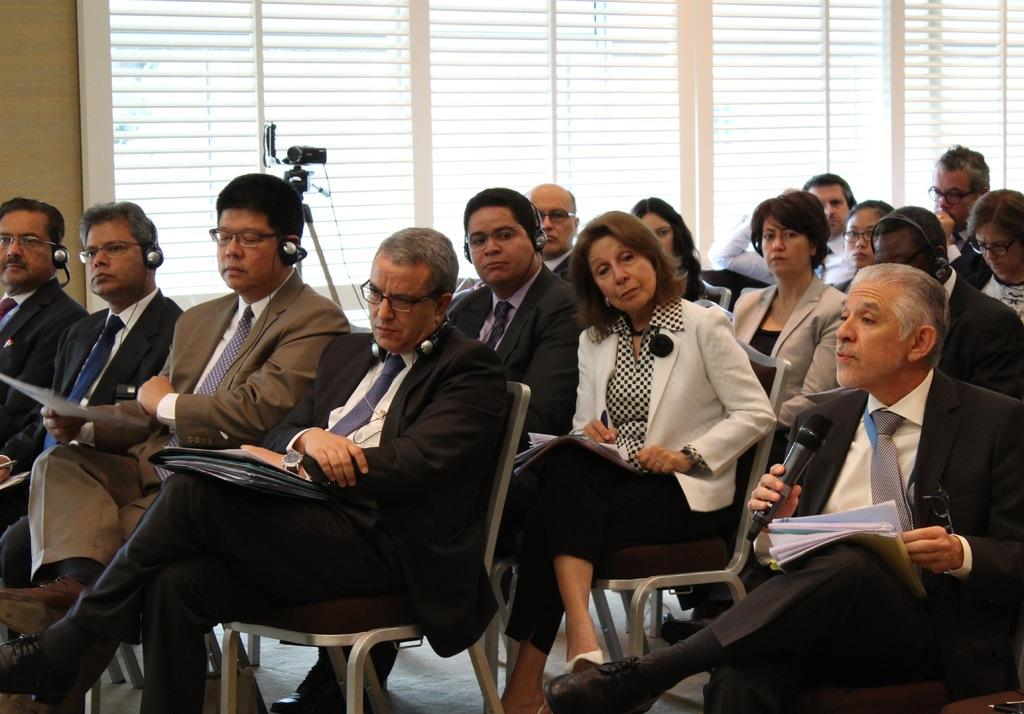What are the people in the image doing? There is a group of persons sitting in the image. What can be seen in the background of the image? There are windows in the background of the image. What object is present in the image that is used for capturing images? There is a camera in the image. How many eggs are visible in the image? There are no eggs present in the image. What type of wing is attached to the camera in the image? There is no wing attached to the camera in the image. 